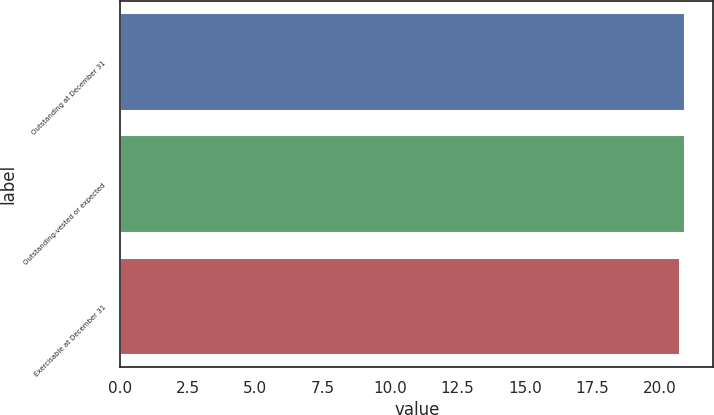Convert chart. <chart><loc_0><loc_0><loc_500><loc_500><bar_chart><fcel>Outstanding at December 31<fcel>Outstanding-vested or expected<fcel>Exercisable at December 31<nl><fcel>20.92<fcel>20.94<fcel>20.75<nl></chart> 